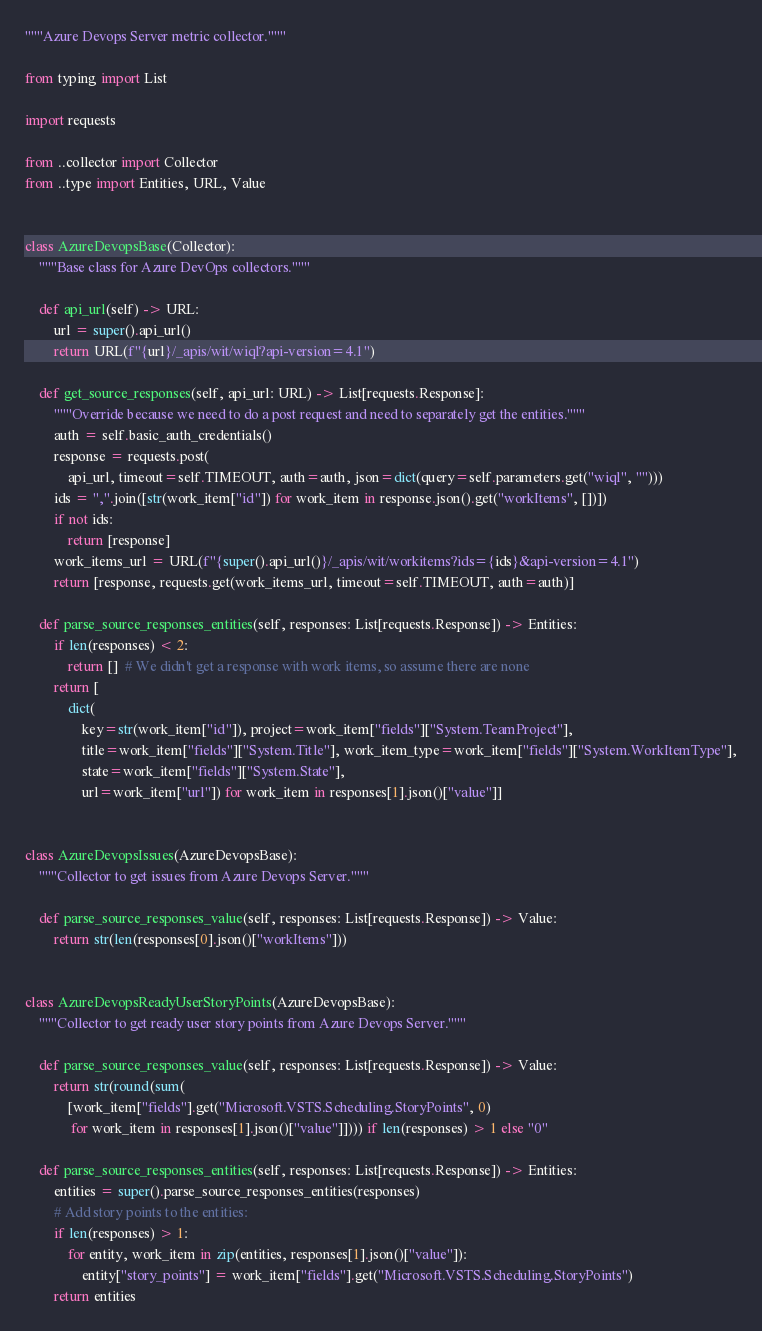<code> <loc_0><loc_0><loc_500><loc_500><_Python_>"""Azure Devops Server metric collector."""

from typing import List

import requests

from ..collector import Collector
from ..type import Entities, URL, Value


class AzureDevopsBase(Collector):
    """Base class for Azure DevOps collectors."""

    def api_url(self) -> URL:
        url = super().api_url()
        return URL(f"{url}/_apis/wit/wiql?api-version=4.1")

    def get_source_responses(self, api_url: URL) -> List[requests.Response]:
        """Override because we need to do a post request and need to separately get the entities."""
        auth = self.basic_auth_credentials()
        response = requests.post(
            api_url, timeout=self.TIMEOUT, auth=auth, json=dict(query=self.parameters.get("wiql", "")))
        ids = ",".join([str(work_item["id"]) for work_item in response.json().get("workItems", [])])
        if not ids:
            return [response]
        work_items_url = URL(f"{super().api_url()}/_apis/wit/workitems?ids={ids}&api-version=4.1")
        return [response, requests.get(work_items_url, timeout=self.TIMEOUT, auth=auth)]

    def parse_source_responses_entities(self, responses: List[requests.Response]) -> Entities:
        if len(responses) < 2:
            return []  # We didn't get a response with work items, so assume there are none
        return [
            dict(
                key=str(work_item["id"]), project=work_item["fields"]["System.TeamProject"],
                title=work_item["fields"]["System.Title"], work_item_type=work_item["fields"]["System.WorkItemType"],
                state=work_item["fields"]["System.State"],
                url=work_item["url"]) for work_item in responses[1].json()["value"]]


class AzureDevopsIssues(AzureDevopsBase):
    """Collector to get issues from Azure Devops Server."""

    def parse_source_responses_value(self, responses: List[requests.Response]) -> Value:
        return str(len(responses[0].json()["workItems"]))


class AzureDevopsReadyUserStoryPoints(AzureDevopsBase):
    """Collector to get ready user story points from Azure Devops Server."""

    def parse_source_responses_value(self, responses: List[requests.Response]) -> Value:
        return str(round(sum(
            [work_item["fields"].get("Microsoft.VSTS.Scheduling.StoryPoints", 0)
             for work_item in responses[1].json()["value"]]))) if len(responses) > 1 else "0"

    def parse_source_responses_entities(self, responses: List[requests.Response]) -> Entities:
        entities = super().parse_source_responses_entities(responses)
        # Add story points to the entities:
        if len(responses) > 1:
            for entity, work_item in zip(entities, responses[1].json()["value"]):
                entity["story_points"] = work_item["fields"].get("Microsoft.VSTS.Scheduling.StoryPoints")
        return entities
</code> 